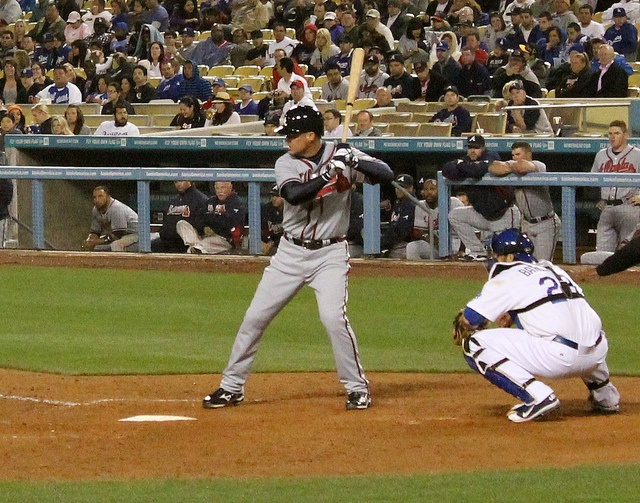Describe the objects in this image and their specific colors. I can see people in gray and black tones, people in gray, lavender, black, olive, and darkgray tones, people in gray, darkgray, black, and lightgray tones, people in gray and black tones, and people in gray, darkgray, and black tones in this image. 